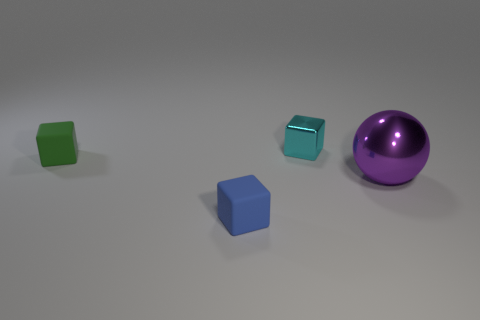How many tiny objects are matte objects or matte spheres?
Ensure brevity in your answer.  2. What size is the object that is both to the right of the tiny blue thing and in front of the cyan block?
Your answer should be compact. Large. There is a shiny block; what number of purple shiny spheres are behind it?
Ensure brevity in your answer.  0. There is a object that is in front of the green rubber thing and behind the small blue rubber thing; what shape is it?
Your answer should be compact. Sphere. How many blocks are either big purple metal things or green shiny objects?
Offer a very short reply. 0. Are there fewer things that are in front of the cyan shiny cube than matte cubes?
Provide a succinct answer. No. There is a tiny thing that is in front of the cyan metallic block and behind the tiny blue object; what is its color?
Your answer should be compact. Green. What number of other objects are there of the same shape as the small green matte object?
Provide a short and direct response. 2. Are there fewer large metal balls on the left side of the purple thing than rubber blocks in front of the small green rubber block?
Offer a terse response. Yes. Is the large sphere made of the same material as the object to the left of the blue cube?
Ensure brevity in your answer.  No. 